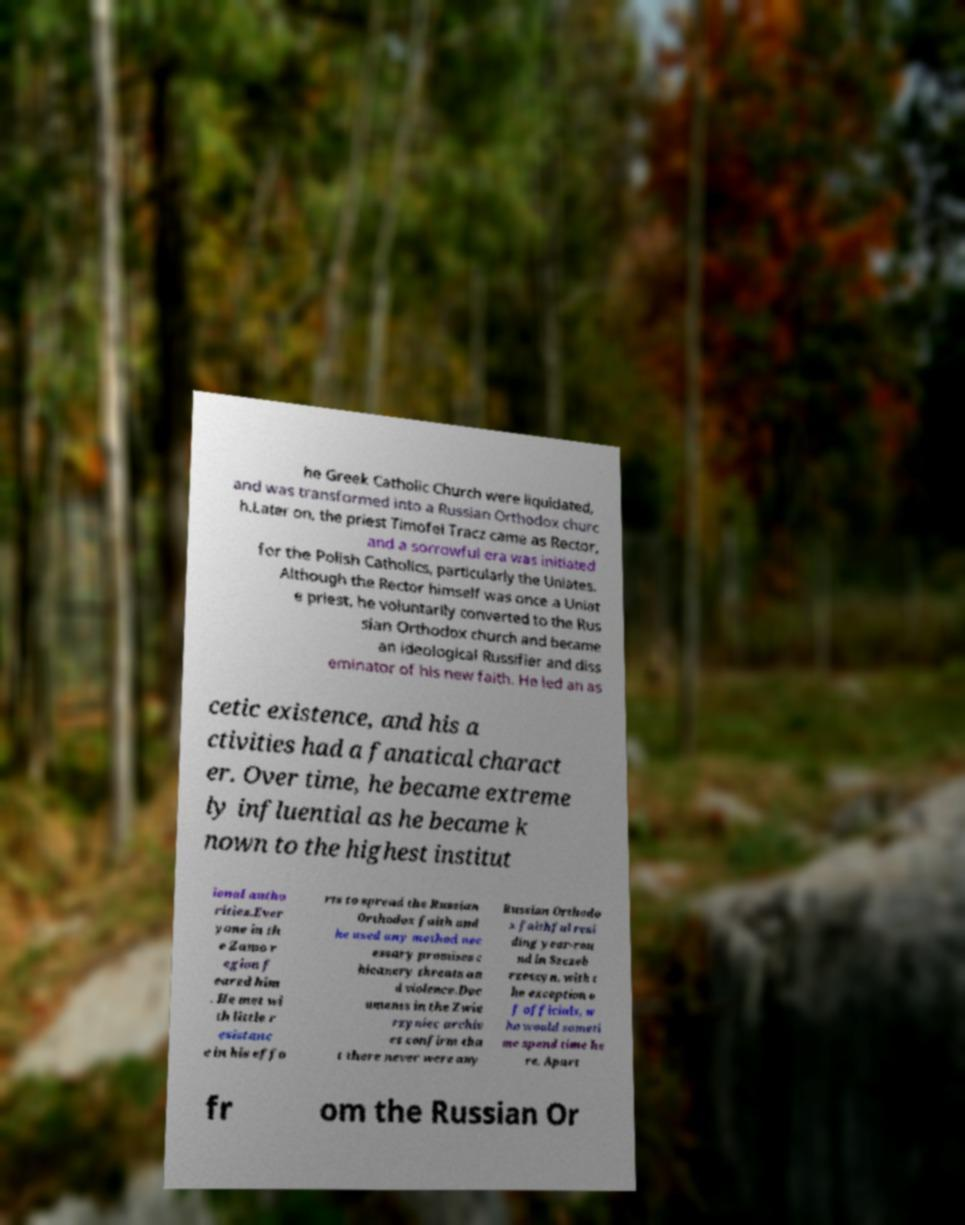Could you assist in decoding the text presented in this image and type it out clearly? he Greek Catholic Church were liquidated, and was transformed into a Russian Orthodox churc h.Later on, the priest Timofei Tracz came as Rector, and a sorrowful era was initiated for the Polish Catholics, particularly the Uniates. Although the Rector himself was once a Uniat e priest, he voluntarily converted to the Rus sian Orthodox church and became an ideological Russifier and diss eminator of his new faith. He led an as cetic existence, and his a ctivities had a fanatical charact er. Over time, he became extreme ly influential as he became k nown to the highest institut ional autho rities.Ever yone in th e Zamo r egion f eared him . He met wi th little r esistanc e in his effo rts to spread the Russian Orthodox faith and he used any method nec essary promises c hicanery threats an d violence.Doc uments in the Zwie rzyniec archiv es confirm tha t there never were any Russian Orthodo x faithful resi ding year-rou nd in Szczeb rzeszyn, with t he exception o f officials, w ho would someti me spend time he re. Apart fr om the Russian Or 